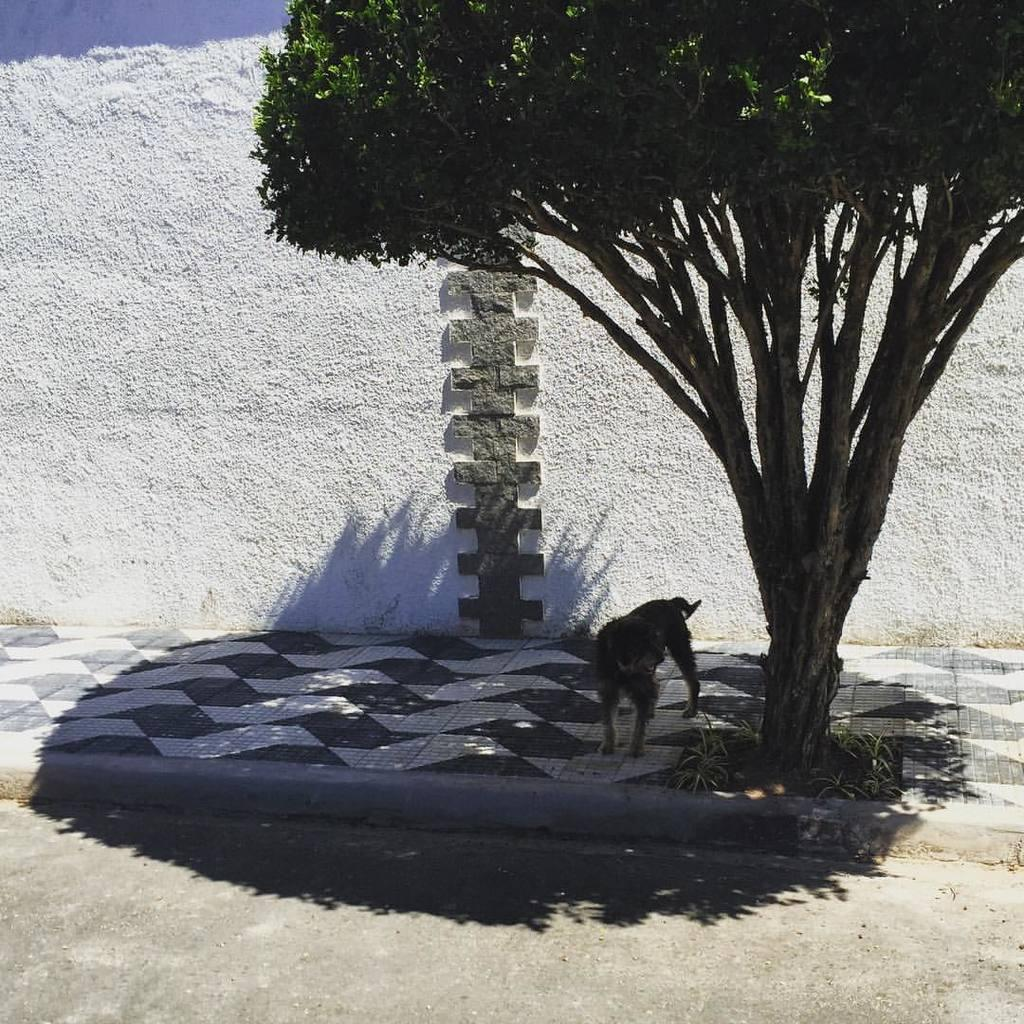What type of structure is visible in the image? There is a wall in the image. What type of animal can be seen in the image? There is a dog in the image. What type of plant is present in the image? There is a tree in the image. Can you tell me how many flowers are on the tree in the image? There are no flowers mentioned or visible on the tree in the image. Is there a toad sitting on the wall in the image? There is no toad present in the image. 